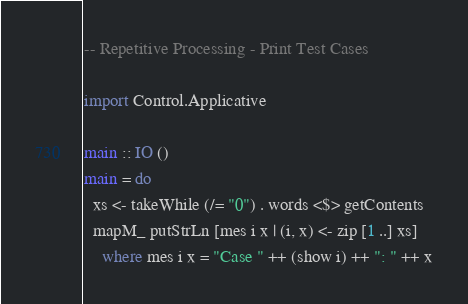<code> <loc_0><loc_0><loc_500><loc_500><_Haskell_>-- Repetitive Processing - Print Test Cases

import Control.Applicative

main :: IO ()
main = do
  xs <- takeWhile (/= "0") . words <$> getContents
  mapM_ putStrLn [mes i x | (i, x) <- zip [1 ..] xs]
    where mes i x = "Case " ++ (show i) ++ ": " ++ x

</code> 